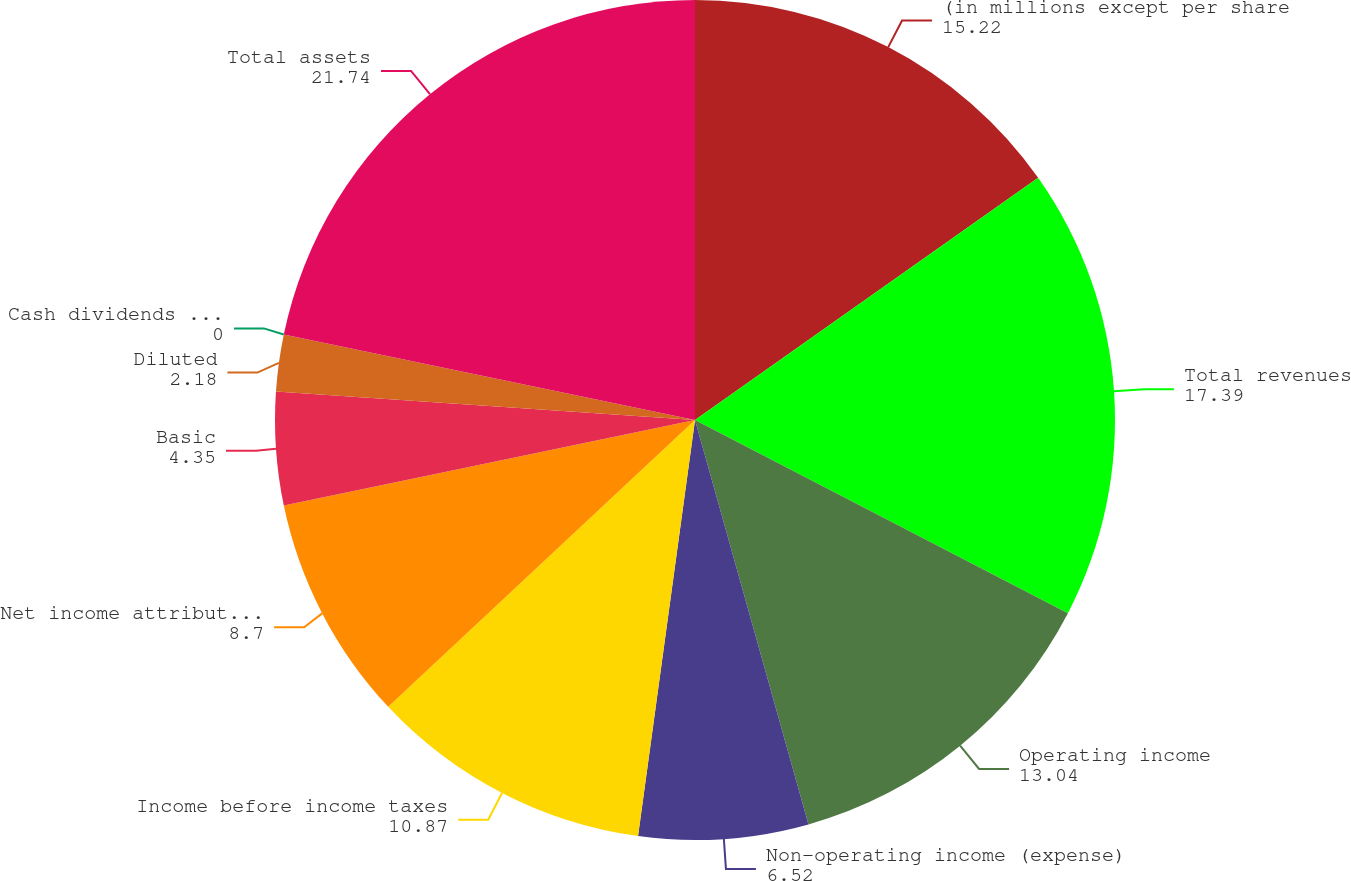<chart> <loc_0><loc_0><loc_500><loc_500><pie_chart><fcel>(in millions except per share<fcel>Total revenues<fcel>Operating income<fcel>Non-operating income (expense)<fcel>Income before income taxes<fcel>Net income attributable to CME<fcel>Basic<fcel>Diluted<fcel>Cash dividends per share<fcel>Total assets<nl><fcel>15.22%<fcel>17.39%<fcel>13.04%<fcel>6.52%<fcel>10.87%<fcel>8.7%<fcel>4.35%<fcel>2.18%<fcel>0.0%<fcel>21.74%<nl></chart> 